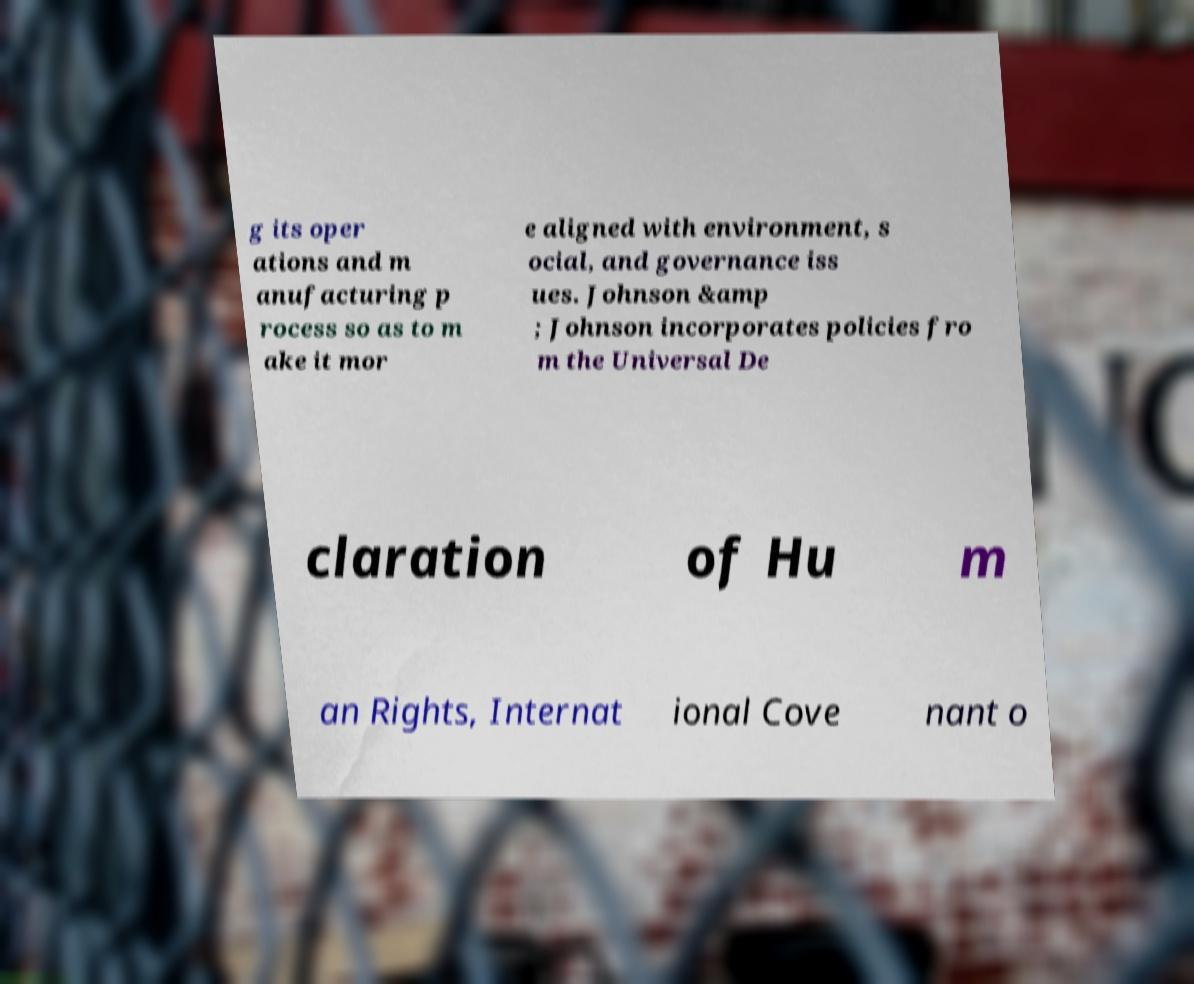Can you read and provide the text displayed in the image?This photo seems to have some interesting text. Can you extract and type it out for me? g its oper ations and m anufacturing p rocess so as to m ake it mor e aligned with environment, s ocial, and governance iss ues. Johnson &amp ; Johnson incorporates policies fro m the Universal De claration of Hu m an Rights, Internat ional Cove nant o 